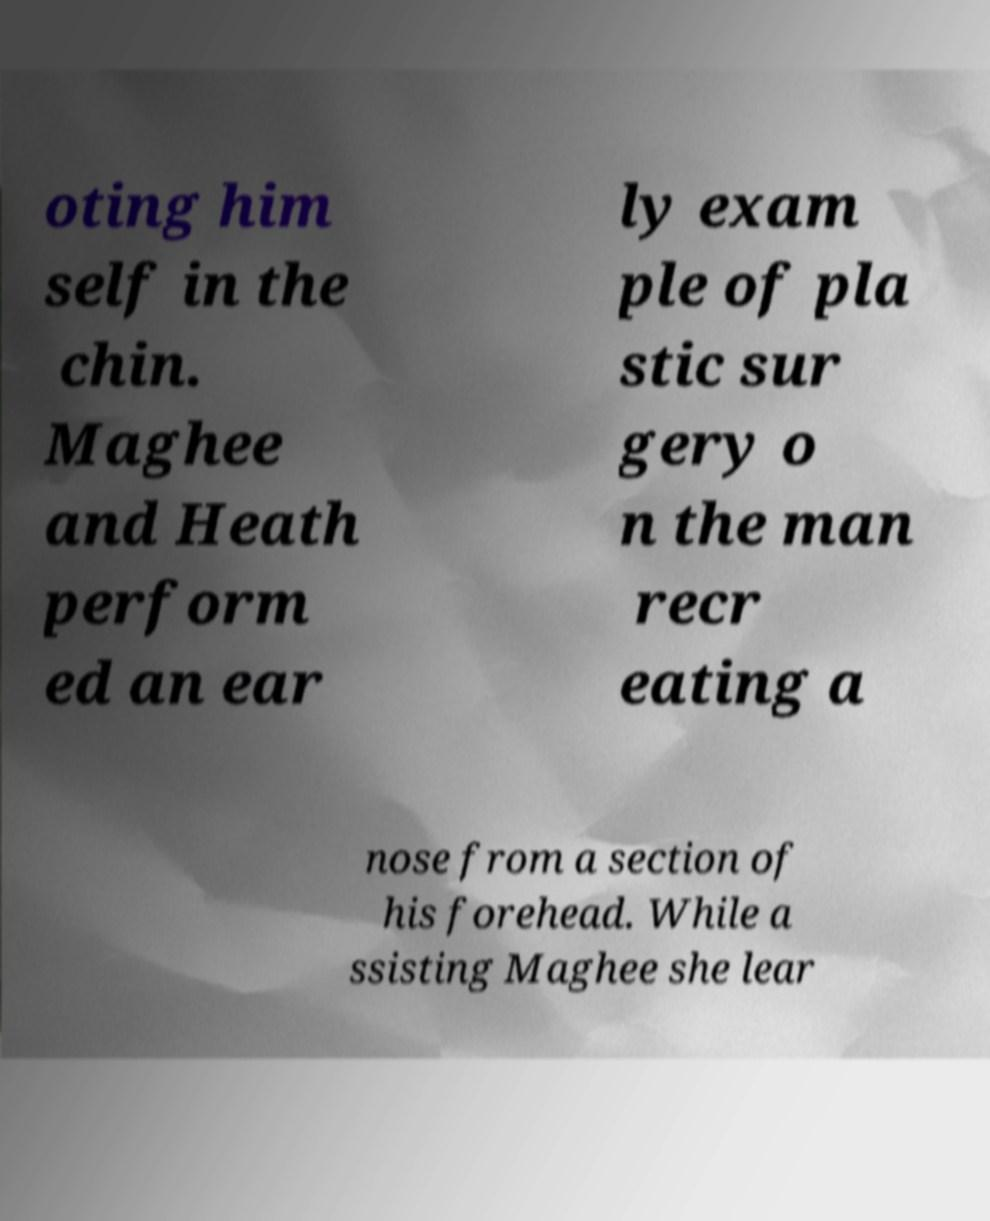I need the written content from this picture converted into text. Can you do that? oting him self in the chin. Maghee and Heath perform ed an ear ly exam ple of pla stic sur gery o n the man recr eating a nose from a section of his forehead. While a ssisting Maghee she lear 